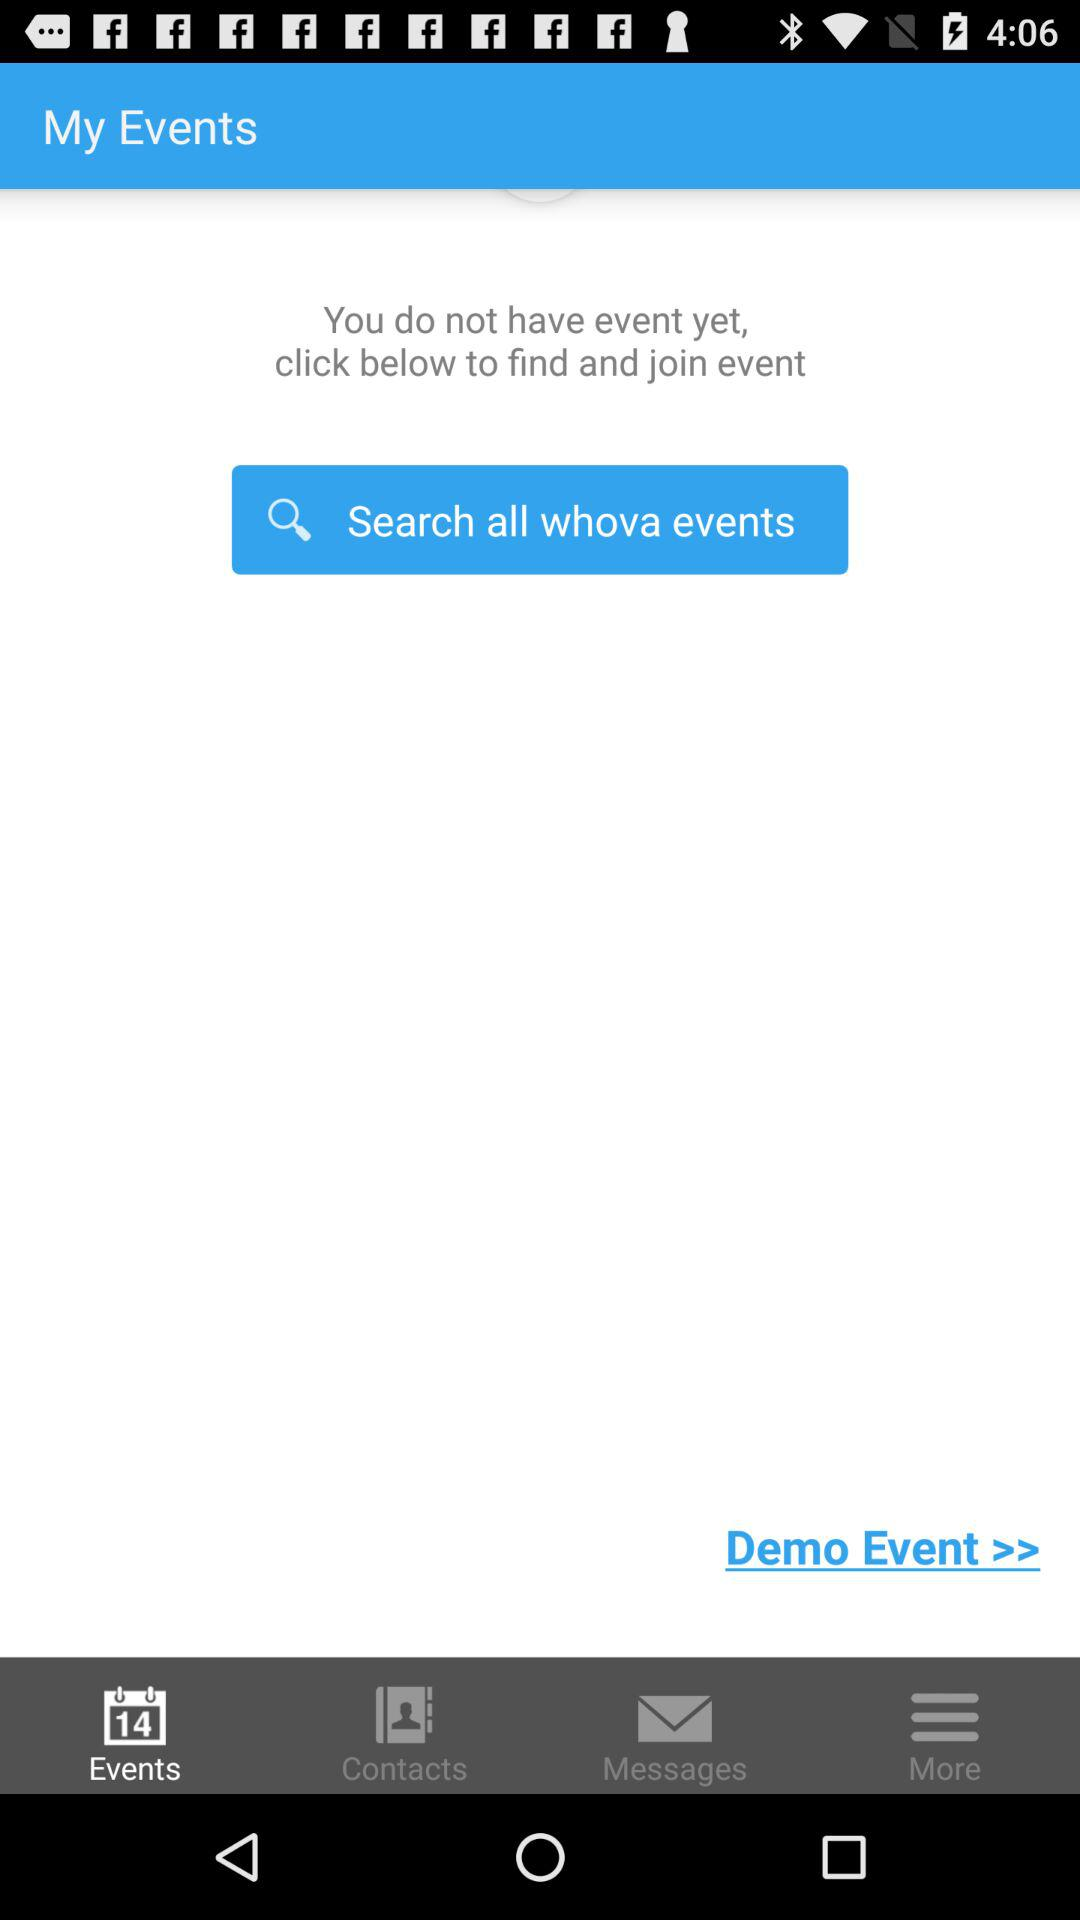Which tab is open? The open tab is "Events". 